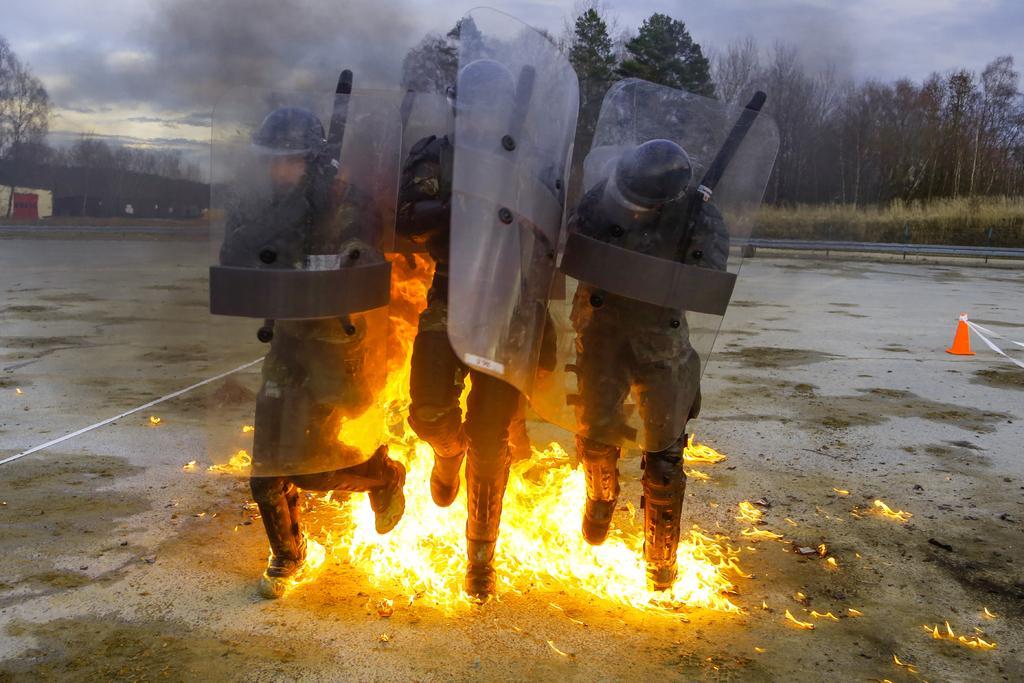Please provide a concise description of this image. In this image there are three men running. They are holding bullet proof shields. Behind them there is the fire on the ground. To the right there is a cone barrier on the ground. In the background there trees, mountains and plants. At the top there is the sky. 